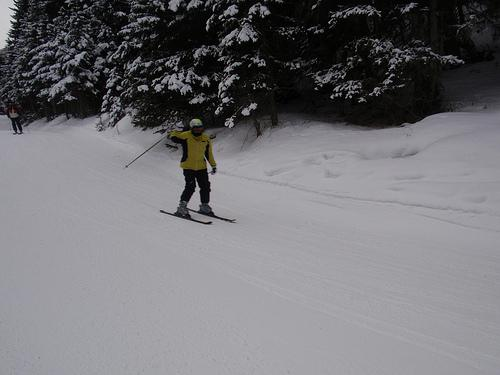Question: when was this photo taken?
Choices:
A. During winter.
B. Summer.
C. Fall.
D. Spring.
Answer with the letter. Answer: A Question: who is in the photo?
Choices:
A. A guy skateboarding.
B. A man.
C. A guy surfing.
D. A woman wearing a ponytail.
Answer with the letter. Answer: B Question: what is the man wearing?
Choices:
A. A yellow and black jacket, black pants and skies.
B. A red tie.
C. A yellow shirt.
D. A black shirt.
Answer with the letter. Answer: A Question: what does the skier have in his hand?
Choices:
A. His gloves.
B. His goggles.
C. A cellphone.
D. A long ski pole.
Answer with the letter. Answer: D Question: what time of day was this photo taken?
Choices:
A. Before the evening.
B. Afternoon.
C. At night.
D. Morning.
Answer with the letter. Answer: A Question: what is on the skier's head?
Choices:
A. A helmet.
B. Goggles.
C. A hat.
D. A scarf.
Answer with the letter. Answer: A 